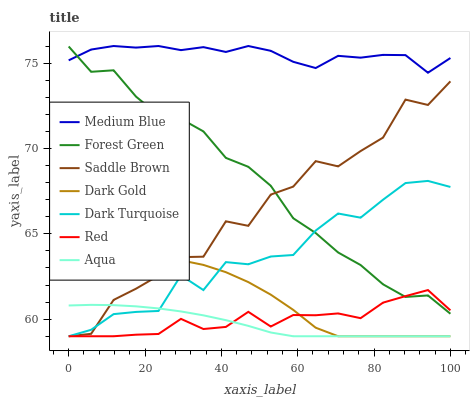Does Aqua have the minimum area under the curve?
Answer yes or no. Yes. Does Medium Blue have the maximum area under the curve?
Answer yes or no. Yes. Does Dark Turquoise have the minimum area under the curve?
Answer yes or no. No. Does Dark Turquoise have the maximum area under the curve?
Answer yes or no. No. Is Aqua the smoothest?
Answer yes or no. Yes. Is Saddle Brown the roughest?
Answer yes or no. Yes. Is Dark Turquoise the smoothest?
Answer yes or no. No. Is Dark Turquoise the roughest?
Answer yes or no. No. Does Dark Gold have the lowest value?
Answer yes or no. Yes. Does Medium Blue have the lowest value?
Answer yes or no. No. Does Medium Blue have the highest value?
Answer yes or no. Yes. Does Dark Turquoise have the highest value?
Answer yes or no. No. Is Dark Gold less than Medium Blue?
Answer yes or no. Yes. Is Medium Blue greater than Aqua?
Answer yes or no. Yes. Does Aqua intersect Dark Turquoise?
Answer yes or no. Yes. Is Aqua less than Dark Turquoise?
Answer yes or no. No. Is Aqua greater than Dark Turquoise?
Answer yes or no. No. Does Dark Gold intersect Medium Blue?
Answer yes or no. No. 